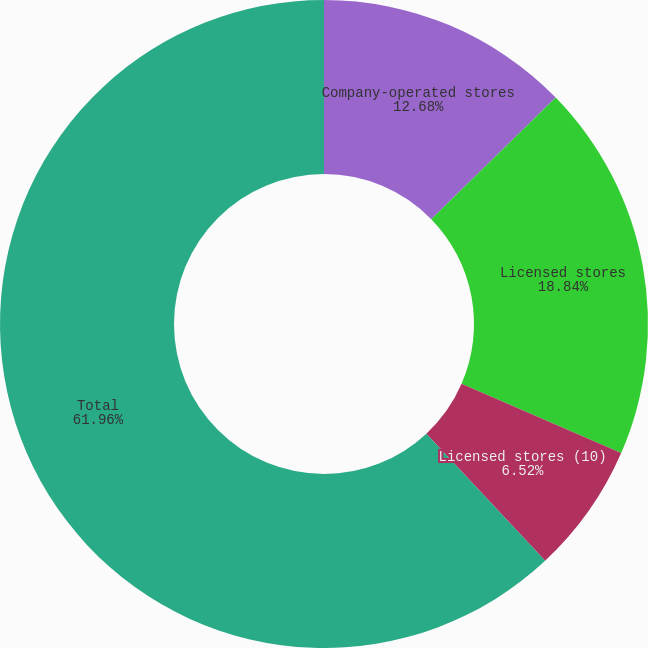Convert chart. <chart><loc_0><loc_0><loc_500><loc_500><pie_chart><fcel>Company-operated stores<fcel>Licensed stores<fcel>Licensed stores (10)<fcel>Total<nl><fcel>12.68%<fcel>18.84%<fcel>6.52%<fcel>61.95%<nl></chart> 